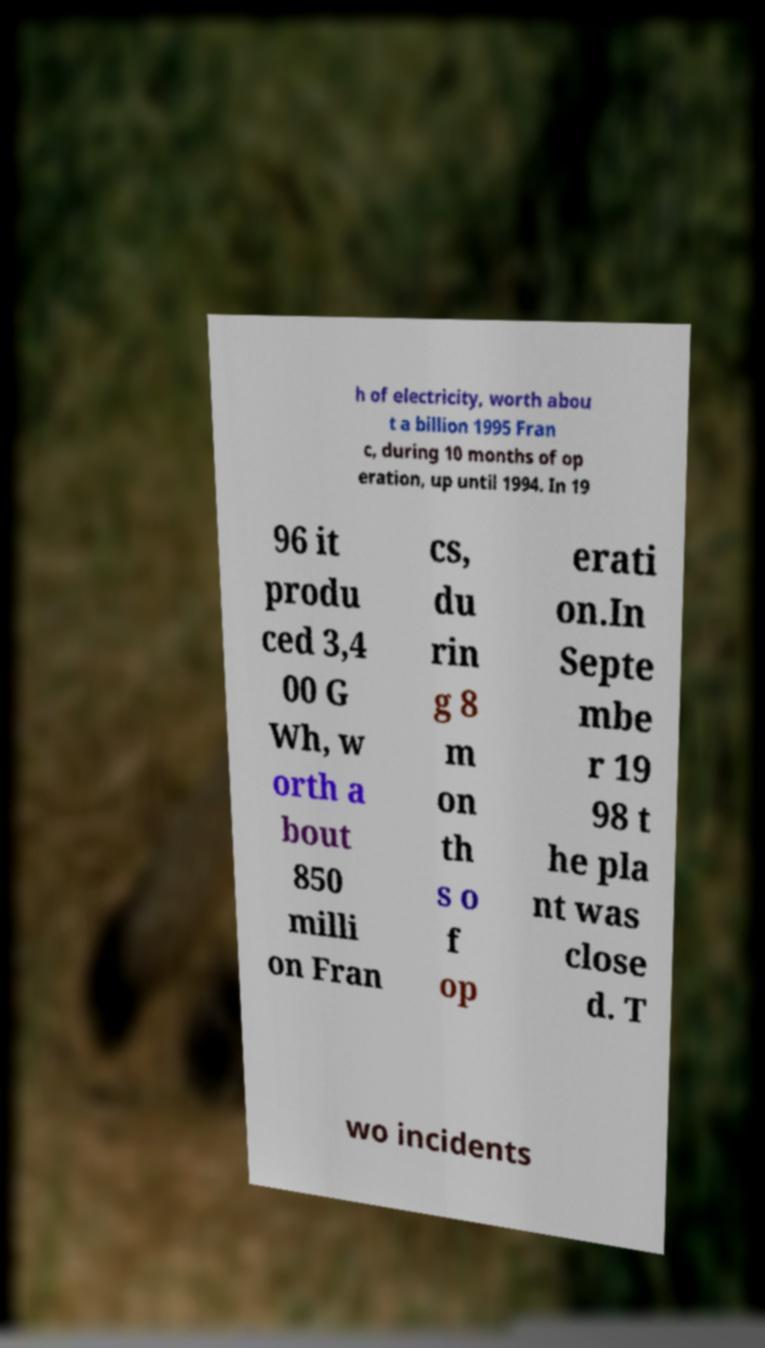Can you read and provide the text displayed in the image?This photo seems to have some interesting text. Can you extract and type it out for me? h of electricity, worth abou t a billion 1995 Fran c, during 10 months of op eration, up until 1994. In 19 96 it produ ced 3,4 00 G Wh, w orth a bout 850 milli on Fran cs, du rin g 8 m on th s o f op erati on.In Septe mbe r 19 98 t he pla nt was close d. T wo incidents 